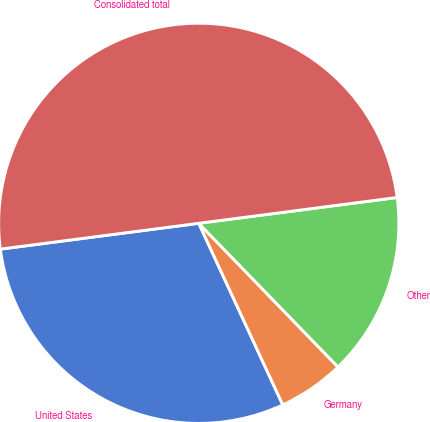Convert chart to OTSL. <chart><loc_0><loc_0><loc_500><loc_500><pie_chart><fcel>United States<fcel>Germany<fcel>Other<fcel>Consolidated total<nl><fcel>29.84%<fcel>5.35%<fcel>14.81%<fcel>50.0%<nl></chart> 